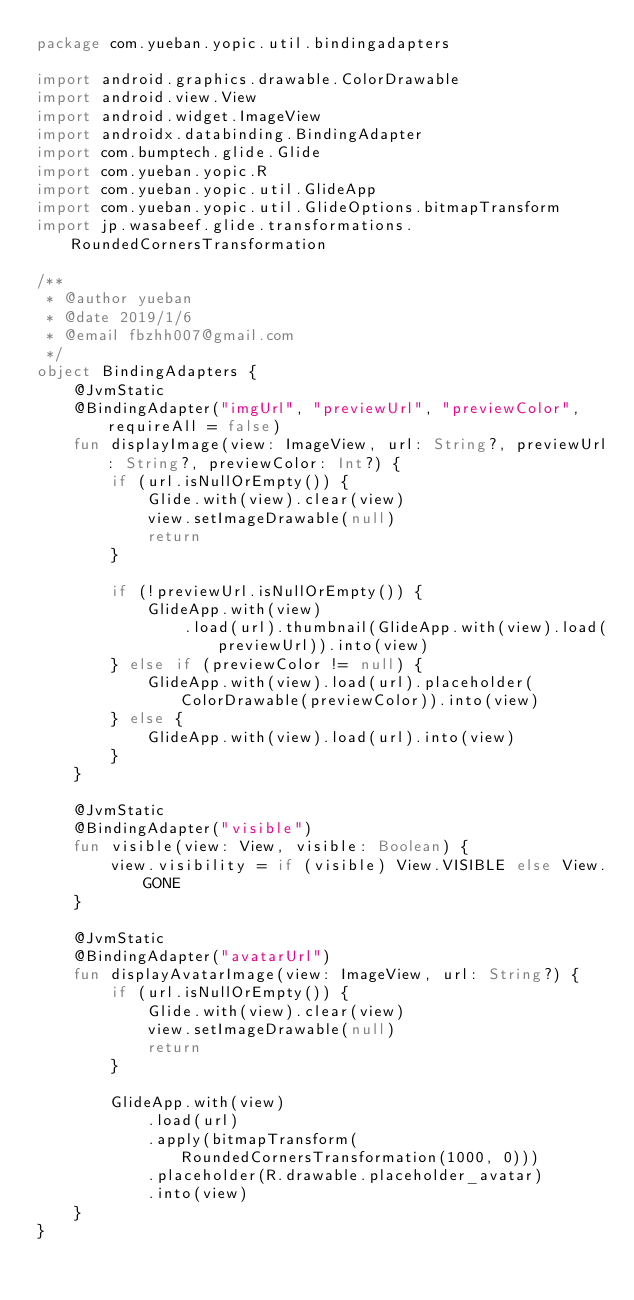<code> <loc_0><loc_0><loc_500><loc_500><_Kotlin_>package com.yueban.yopic.util.bindingadapters

import android.graphics.drawable.ColorDrawable
import android.view.View
import android.widget.ImageView
import androidx.databinding.BindingAdapter
import com.bumptech.glide.Glide
import com.yueban.yopic.R
import com.yueban.yopic.util.GlideApp
import com.yueban.yopic.util.GlideOptions.bitmapTransform
import jp.wasabeef.glide.transformations.RoundedCornersTransformation

/**
 * @author yueban
 * @date 2019/1/6
 * @email fbzhh007@gmail.com
 */
object BindingAdapters {
    @JvmStatic
    @BindingAdapter("imgUrl", "previewUrl", "previewColor", requireAll = false)
    fun displayImage(view: ImageView, url: String?, previewUrl: String?, previewColor: Int?) {
        if (url.isNullOrEmpty()) {
            Glide.with(view).clear(view)
            view.setImageDrawable(null)
            return
        }

        if (!previewUrl.isNullOrEmpty()) {
            GlideApp.with(view)
                .load(url).thumbnail(GlideApp.with(view).load(previewUrl)).into(view)
        } else if (previewColor != null) {
            GlideApp.with(view).load(url).placeholder(ColorDrawable(previewColor)).into(view)
        } else {
            GlideApp.with(view).load(url).into(view)
        }
    }

    @JvmStatic
    @BindingAdapter("visible")
    fun visible(view: View, visible: Boolean) {
        view.visibility = if (visible) View.VISIBLE else View.GONE
    }

    @JvmStatic
    @BindingAdapter("avatarUrl")
    fun displayAvatarImage(view: ImageView, url: String?) {
        if (url.isNullOrEmpty()) {
            Glide.with(view).clear(view)
            view.setImageDrawable(null)
            return
        }

        GlideApp.with(view)
            .load(url)
            .apply(bitmapTransform(RoundedCornersTransformation(1000, 0)))
            .placeholder(R.drawable.placeholder_avatar)
            .into(view)
    }
}
</code> 